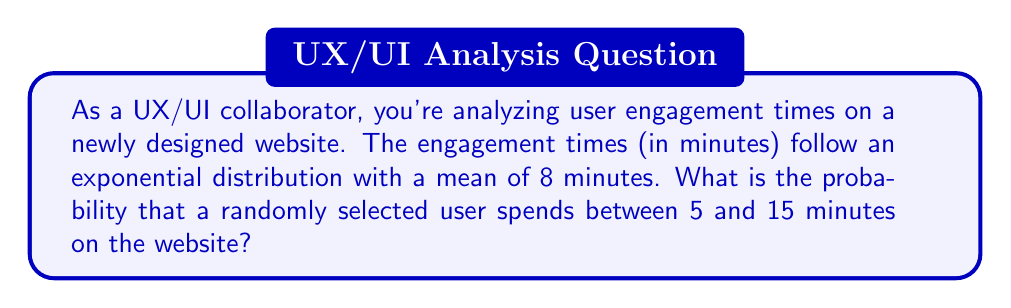Help me with this question. Let's approach this step-by-step:

1) For an exponential distribution, the probability density function is given by:

   $$f(x) = \lambda e^{-\lambda x}$$

   where $\lambda$ is the rate parameter.

2) We're given that the mean is 8 minutes. For an exponential distribution, the mean is $\frac{1}{\lambda}$. So:

   $$\frac{1}{\lambda} = 8$$
   $$\lambda = \frac{1}{8}$$

3) The probability of the engagement time $X$ being between 5 and 15 minutes is:

   $$P(5 < X < 15) = \int_5^{15} \frac{1}{8} e^{-\frac{x}{8}} dx$$

4) To solve this integral, we can use the cumulative distribution function (CDF) of the exponential distribution:

   $$F(x) = 1 - e^{-\lambda x}$$

5) Therefore:

   $$P(5 < X < 15) = F(15) - F(5)$$
   $$= (1 - e^{-\frac{15}{8}}) - (1 - e^{-\frac{5}{8}})$$
   $$= e^{-\frac{5}{8}} - e^{-\frac{15}{8}}$$

6) Calculating this:

   $$e^{-\frac{5}{8}} \approx 0.5353$$
   $$e^{-\frac{15}{8}} \approx 0.1535$$

7) Therefore:

   $$P(5 < X < 15) \approx 0.5353 - 0.1535 \approx 0.3818$$
Answer: The probability that a randomly selected user spends between 5 and 15 minutes on the website is approximately 0.3818 or 38.18%. 